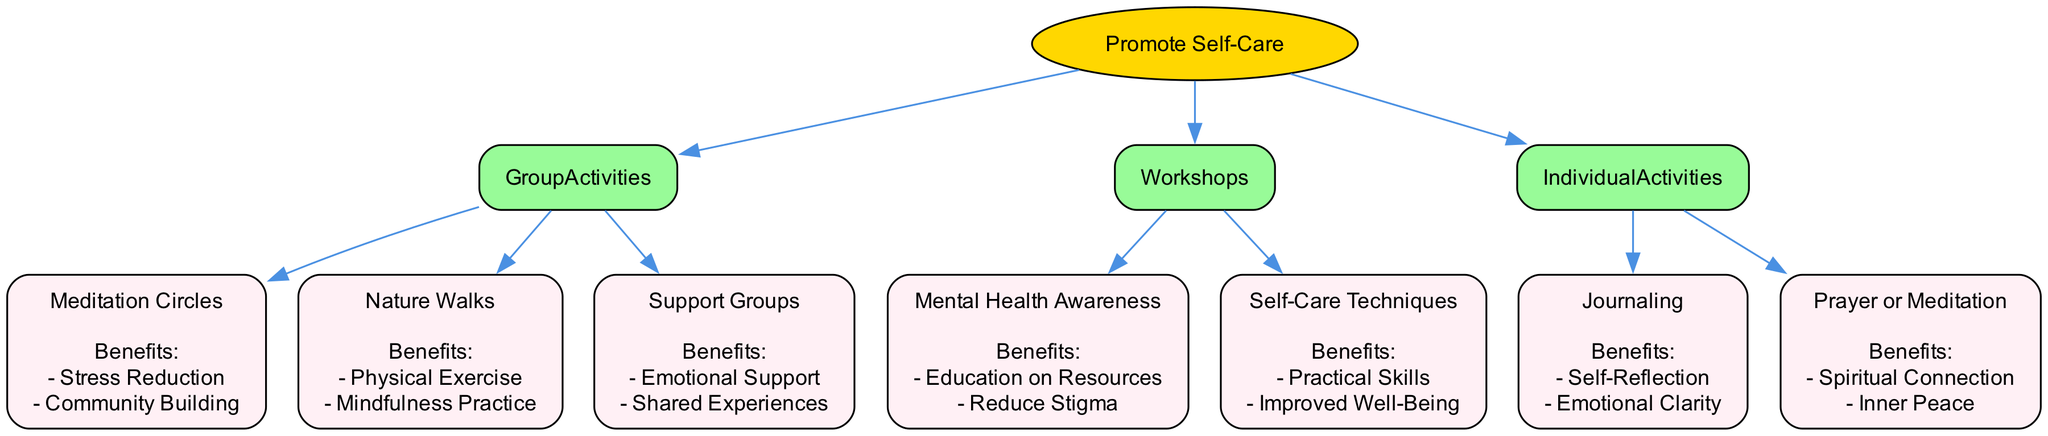What are the three main categories under Evaluate Options? The diagram details three main categories, which are Group Activities, Workshops, and Individual Activities, listed directly under the Evaluate Options section.
Answer: Group Activities, Workshops, Individual Activities How many options are available in the Group Activities category? The Group Activities category features three options: Meditation Circles, Nature Walks, and Support Groups. Therefore, the total count is three.
Answer: 3 What benefits are associated with Nature Walks? From the diagram, Nature Walks provide two specific benefits: Physical Exercise and Mindfulness Practice. Each benefit is mentioned directly under the Nature Walks option.
Answer: Physical Exercise, Mindfulness Practice What is the relationship between Workshops and Mental Health Awareness? The Workshops category contains various options, one of which is Mental Health Awareness. Hence, the relationship is that Mental Health Awareness is an option under Workshops.
Answer: Mental Health Awareness is an option under Workshops Which individual activity focuses on self-reflection? According to the diagram, Journaling is identified as the individual activity that emphasizes self-reflection. This information is located in the Individual Activities category.
Answer: Journaling Which option has the benefit of reducing stigma? The benefit of reducing stigma is linked to the Mental Health Awareness workshop, identified directly as one of its benefits on the diagram.
Answer: Mental Health Awareness How many total options are listed across all categories? By counting the options in each category—3 in Group Activities, 2 in Workshops, and 2 in Individual Activities—there are a total of 3 + 2 + 2 = 7 options.
Answer: 7 What are the benefits of Support Groups? The diagram outlines that Support Groups provide two key benefits: Emotional Support and Shared Experiences, which are explicitly noted under its section in the diagram.
Answer: Emotional Support, Shared Experiences What is the main goal of promoting self-care in a religious community? The overarching aim listed as the root of the diagram is to Promote Self-Care, as seen at the starting point of the decision tree.
Answer: Promote Self-Care 